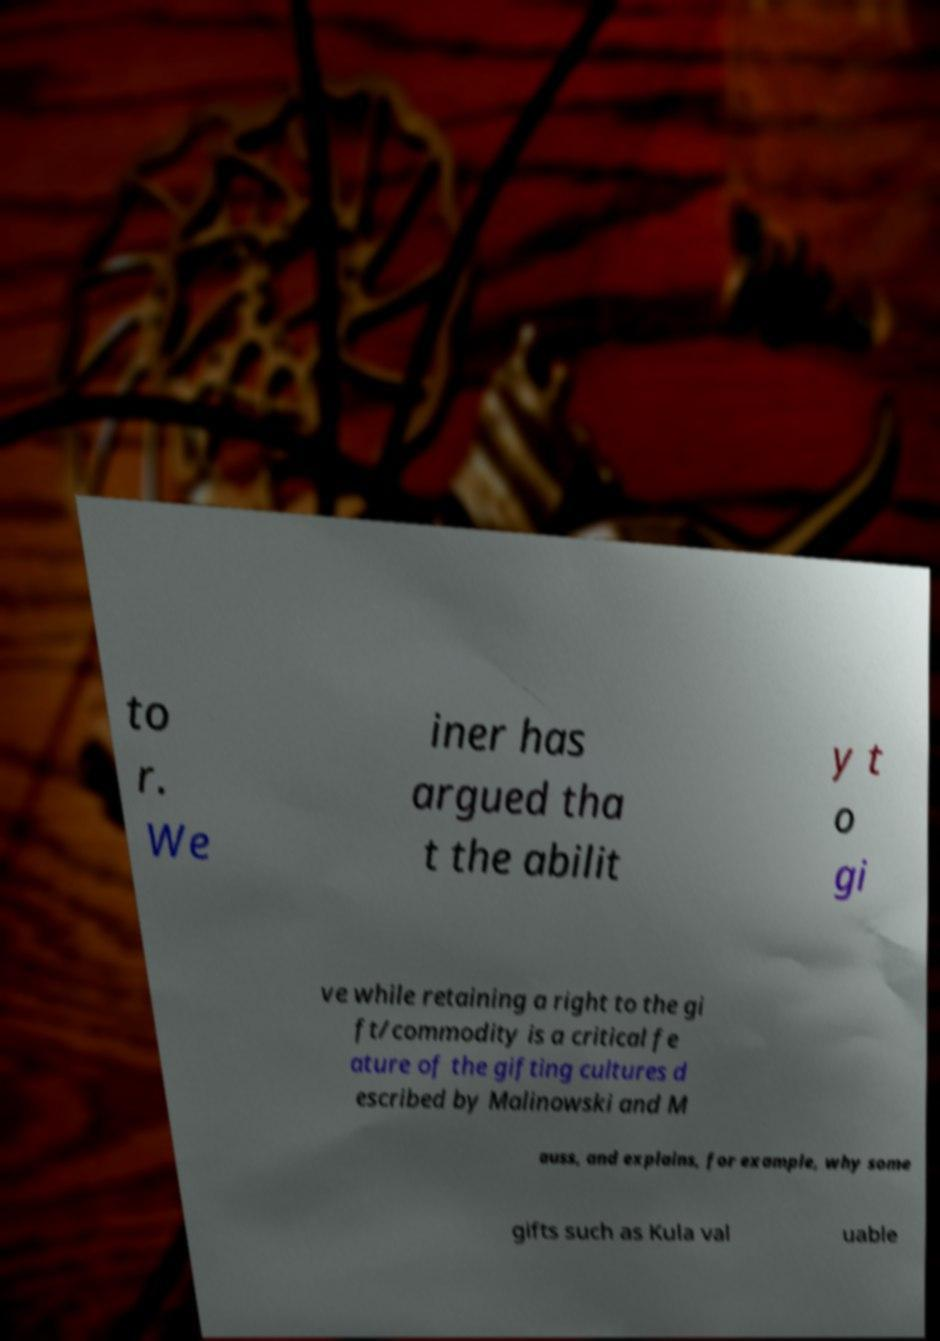For documentation purposes, I need the text within this image transcribed. Could you provide that? to r. We iner has argued tha t the abilit y t o gi ve while retaining a right to the gi ft/commodity is a critical fe ature of the gifting cultures d escribed by Malinowski and M auss, and explains, for example, why some gifts such as Kula val uable 